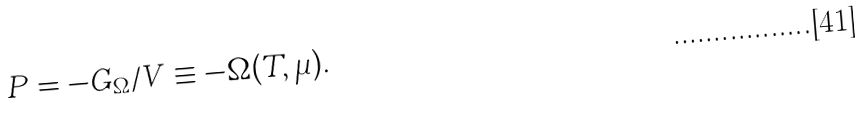<formula> <loc_0><loc_0><loc_500><loc_500>P = - G _ { \Omega } / V \equiv - \Omega ( T , \mu ) .</formula> 